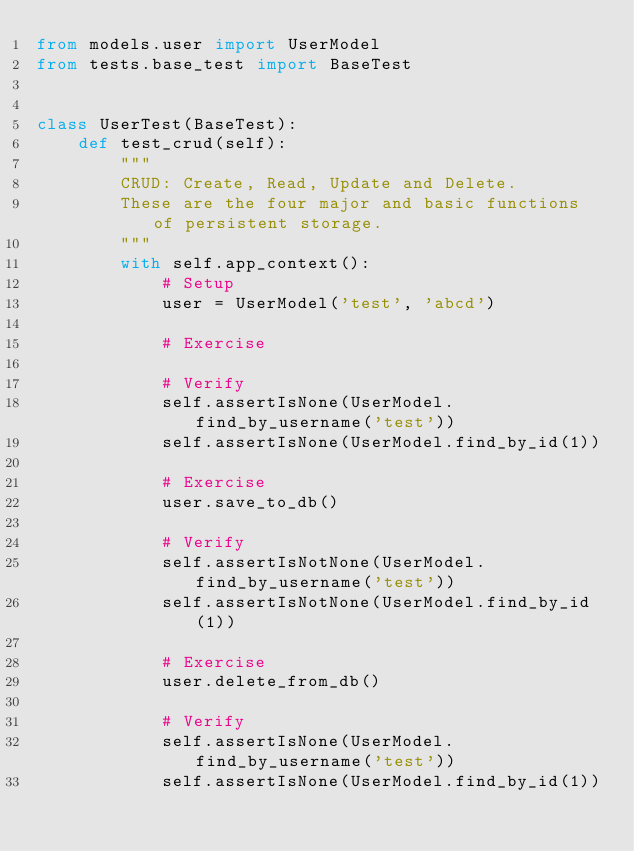Convert code to text. <code><loc_0><loc_0><loc_500><loc_500><_Python_>from models.user import UserModel
from tests.base_test import BaseTest


class UserTest(BaseTest):
    def test_crud(self):
        """
        CRUD: Create, Read, Update and Delete.
        These are the four major and basic functions of persistent storage.
        """
        with self.app_context():
            # Setup
            user = UserModel('test', 'abcd')

            # Exercise

            # Verify
            self.assertIsNone(UserModel.find_by_username('test'))
            self.assertIsNone(UserModel.find_by_id(1))

            # Exercise
            user.save_to_db()

            # Verify
            self.assertIsNotNone(UserModel.find_by_username('test'))
            self.assertIsNotNone(UserModel.find_by_id(1))

            # Exercise
            user.delete_from_db()

            # Verify
            self.assertIsNone(UserModel.find_by_username('test'))
            self.assertIsNone(UserModel.find_by_id(1))
</code> 